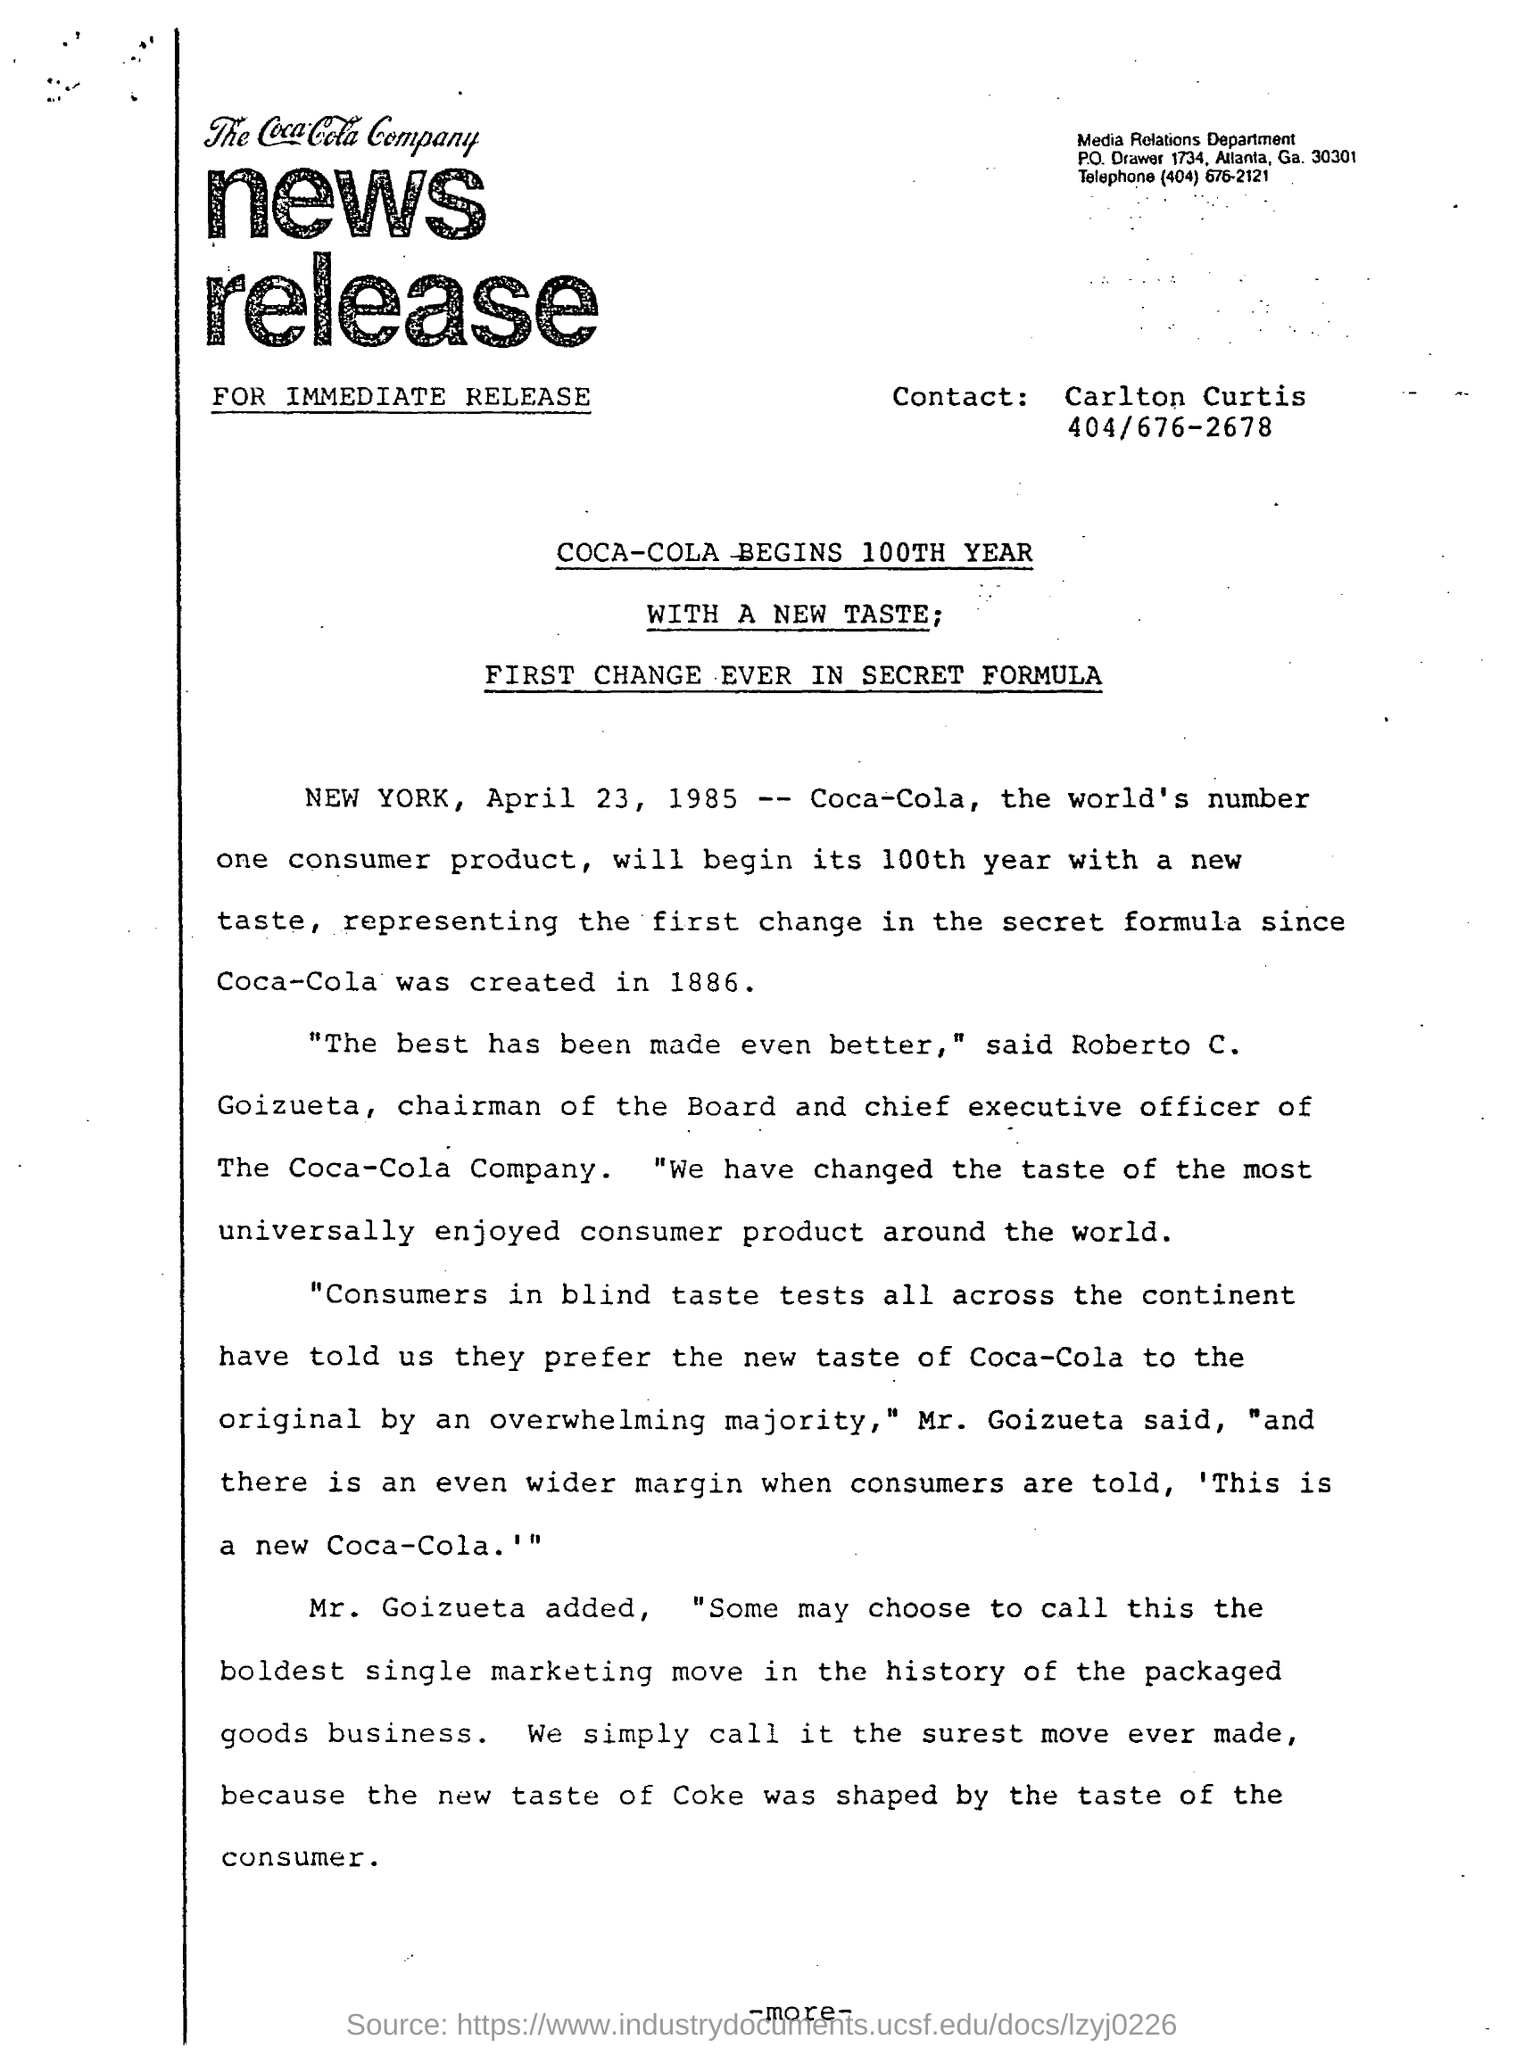Mention a couple of crucial points in this snapshot. I am mentioning the person named Carlton to Contact. The date mentioned is April 23, 1985. Roberto C. Goizueta once said, 'The best has been made even better,' In the year 1919, Coca-Cola first introduced a new taste, marking the start of its 100th anniversary. 